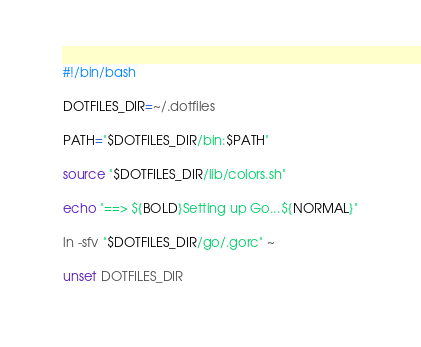<code> <loc_0><loc_0><loc_500><loc_500><_Bash_>#!/bin/bash

DOTFILES_DIR=~/.dotfiles

PATH="$DOTFILES_DIR/bin:$PATH"

source "$DOTFILES_DIR/lib/colors.sh"

echo "==> ${BOLD}Setting up Go...${NORMAL}"

ln -sfv "$DOTFILES_DIR/go/.gorc" ~

unset DOTFILES_DIR
</code> 